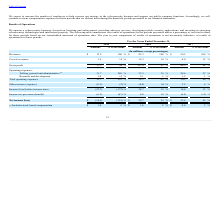From Finjan Holding's financial document, What are the respective revenues from operations in 2018 and 2019 respectively? The document shows two values: $82.3 and $13.2 (in millions). From the document: "Revenues $ 13.2 100 % $ 82.3 100 % $ 50.5 100 % Revenues $ 13.2 100 % $ 82.3 100 % $ 50.5 100 %..." Also, What are the respective cost of revenues from operations in 2018 and 2019 respectively? The document shows two values: 15.3 and 1.9 (in millions). From the document: "Cost of revenues 1.9 14 % 15.3 19 % 6.0 12 % Cost of revenues 1.9 14 % 15.3 19 % 6.0 12 %..." Also, What are the respective gross profit from operations in 2018 and 2019 respectively? The document shows two values: 67.0 and 11.3 (in millions). From the document: "Gross profit 11.3 86 % 67.0 81 % 44.5 88 % Gross profit 11.3 86 % 67.0 81 % 44.5 88 %..." Also, can you calculate: What is the average revenue between 2017 to 2019? To answer this question, I need to perform calculations using the financial data. The calculation is: (50.5 + 82.3 + 13.2)/3 , which equals 48.67 (in millions). This is based on the information: "Revenues $ 13.2 100 % $ 82.3 100 % $ 50.5 100 % Revenues $ 13.2 100 % $ 82.3 100 % $ 50.5 100 % Revenues $ 13.2 100 % $ 82.3 100 % $ 50.5 100 %..." The key data points involved are: 13.2, 50.5, 82.3. Also, can you calculate: What is the percentage change in cost of revenue between 2017 and 2018? To answer this question, I need to perform calculations using the financial data. The calculation is: (15.3-6)/6 , which equals 155 (percentage). This is based on the information: "Cost of revenues 1.9 14 % 15.3 19 % 6.0 12 % Cost of revenues 1.9 14 % 15.3 19 % 6.0 12 %..." The key data points involved are: 15.3, 6. Also, can you calculate: What is the percentage change in gross profit between 2018 and 2019? To answer this question, I need to perform calculations using the financial data. The calculation is: (11.3-67)/67 , which equals -83.13 (percentage). This is based on the information: "Gross profit 11.3 86 % 67.0 81 % 44.5 88 % Gross profit 11.3 86 % 67.0 81 % 44.5 88 %..." The key data points involved are: 11.3, 67. 